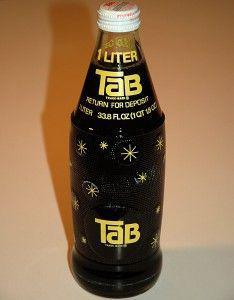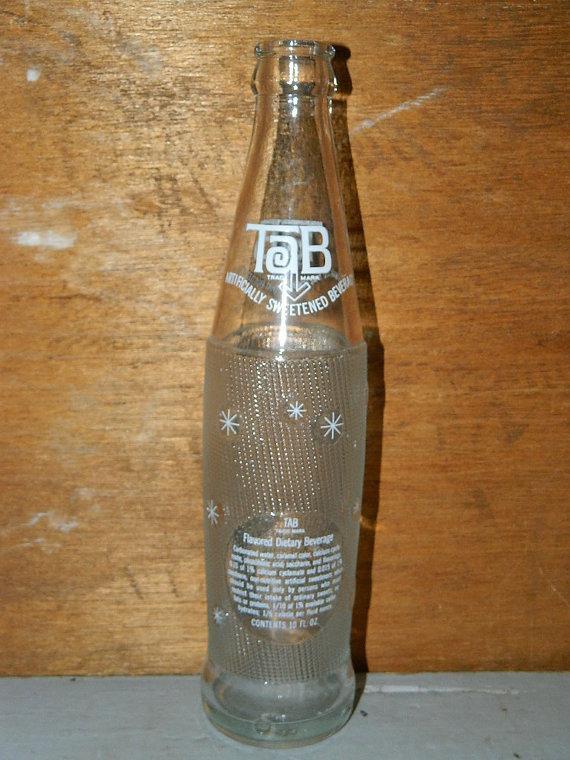The first image is the image on the left, the second image is the image on the right. Analyze the images presented: Is the assertion "One image shows an empty upright bottle with no cap, and the other shows a bottle of dark liquid with a cap on it." valid? Answer yes or no. Yes. The first image is the image on the left, the second image is the image on the right. Examine the images to the left and right. Is the description "The right image contains one glass bottle with a dark colored liquid inside." accurate? Answer yes or no. No. 